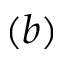<formula> <loc_0><loc_0><loc_500><loc_500>( b )</formula> 